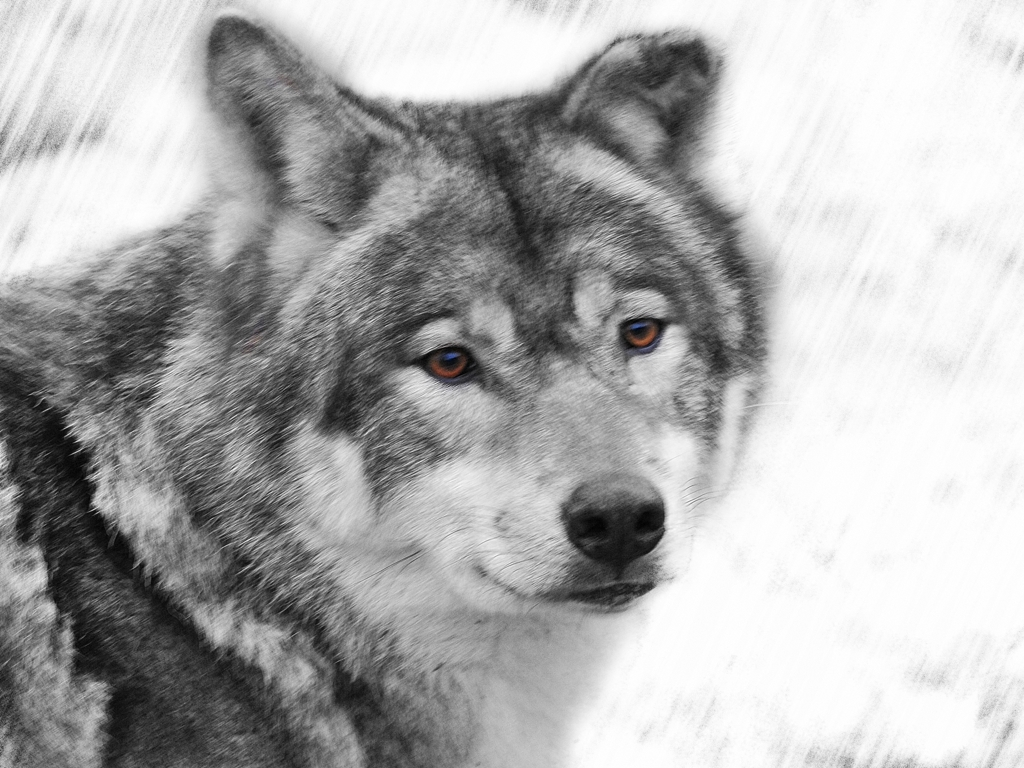Is the focus accurate? The focus on the image appears to be artistically applied, with a selective blurring effect enhancing the wolf's features, particularly its piercing eyes, to draw the viewer's attention. 